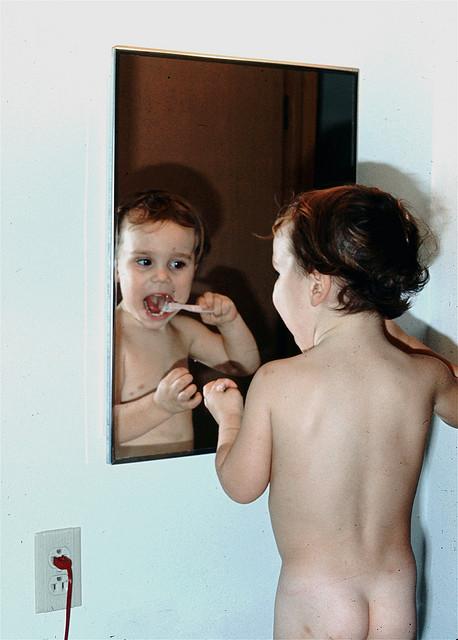What is the baby doing?
Short answer required. Brushing teeth. What is plugged in?
Keep it brief. Red cord. Is he wearing clothes?
Concise answer only. No. 